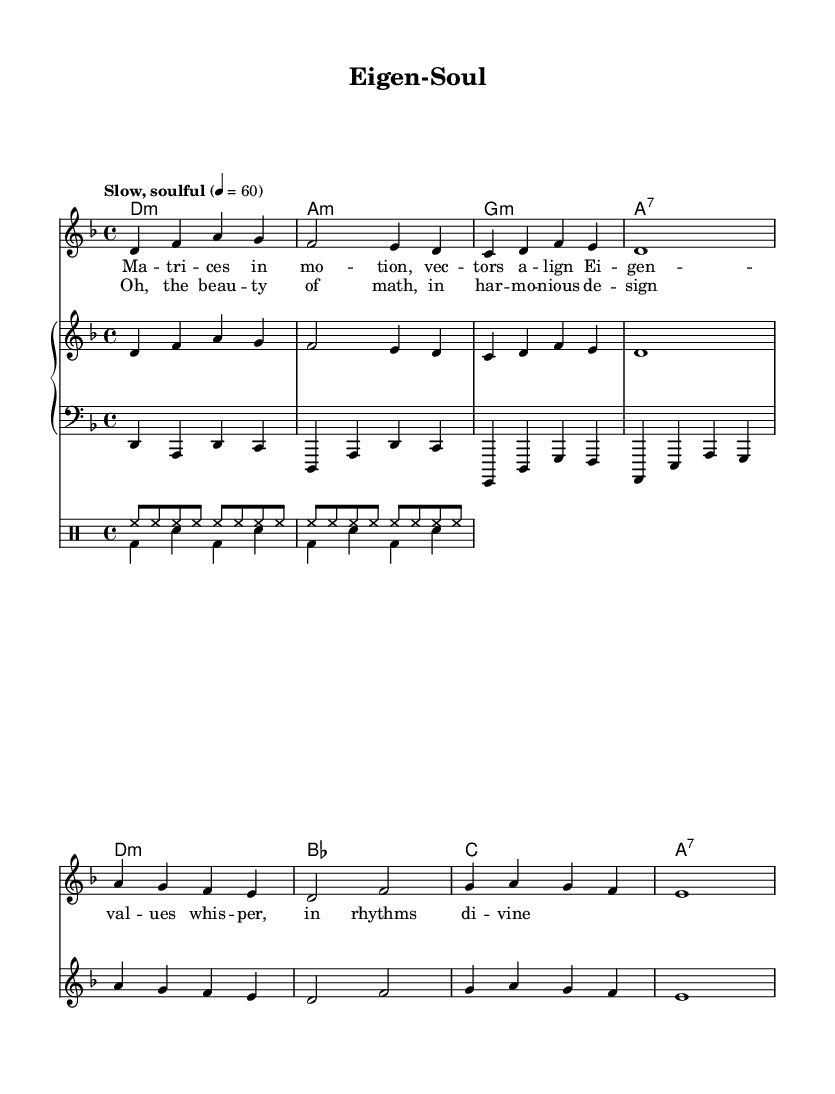What is the key signature of this music? The key signature is indicated at the beginning of the staff. Here, it shows two flats, which corresponds to the key of D minor.
Answer: D minor What is the time signature of the piece? The time signature is located at the beginning of the music, indicated as 4/4, which means four beats per measure and a quarter note gets one beat.
Answer: 4/4 What is the tempo marking for this piece? The tempo is specified in the score as "Slow, soulful" with a metronome marking of quarter note equals 60. This indicates a slower pace for the song.
Answer: Slow, soulful How many measures are in the verse section? The verse is composed of four lines, with each line containing four measures of music. Counting these gives a total of sixteen measures for the verse.
Answer: Sixteen What type of chord does the piece start with? The first chord seen in the harmony section is labeled as d minor. This indicates that the piece begins with a D minor chord.
Answer: D minor What is the mood conveyed by the lyrics? The lyrics reflect themes of introspection and complexity, especially with words like "Matrix" and "Eigenvalues," suggesting a contemplative mood tied to mathematical concepts.
Answer: Introspective How do the chorus lyrics relate to the overall theme of the song? The chorus lyrics express admiration for the beauty of mathematics, suggesting a harmonious relationship between math and art, aligning with soulful music values.
Answer: Harmony of math and beauty 